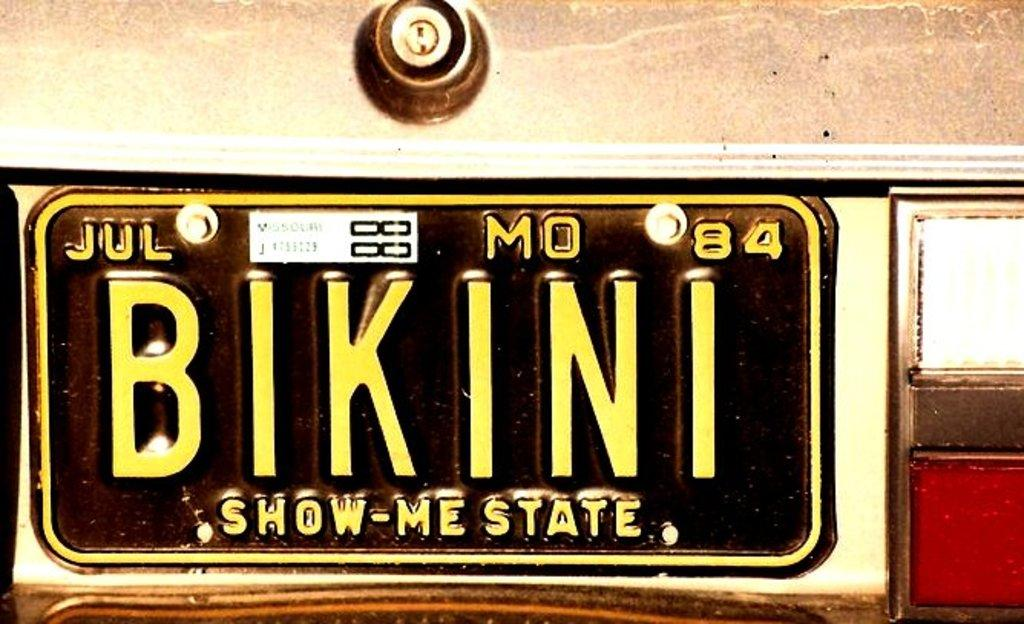<image>
Provide a brief description of the given image. A 1984 state of Missouri license plate that says "Bikini". 